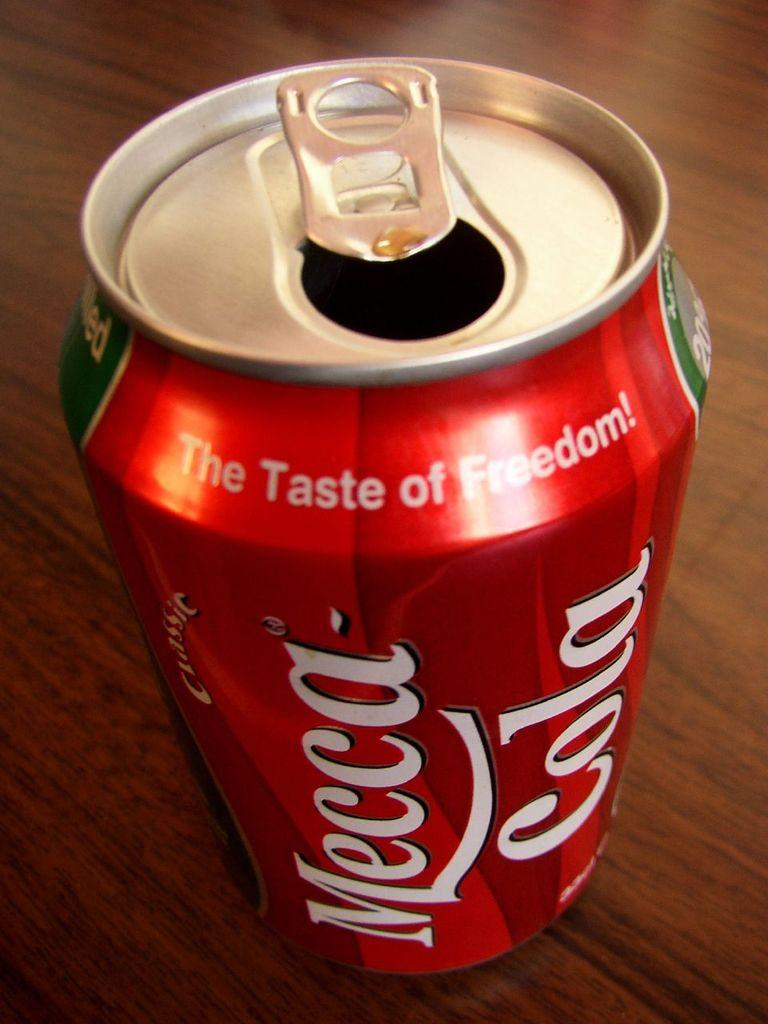<image>
Summarize the visual content of the image. A red can of soda that says Mecca Cola is on a wooden table. 